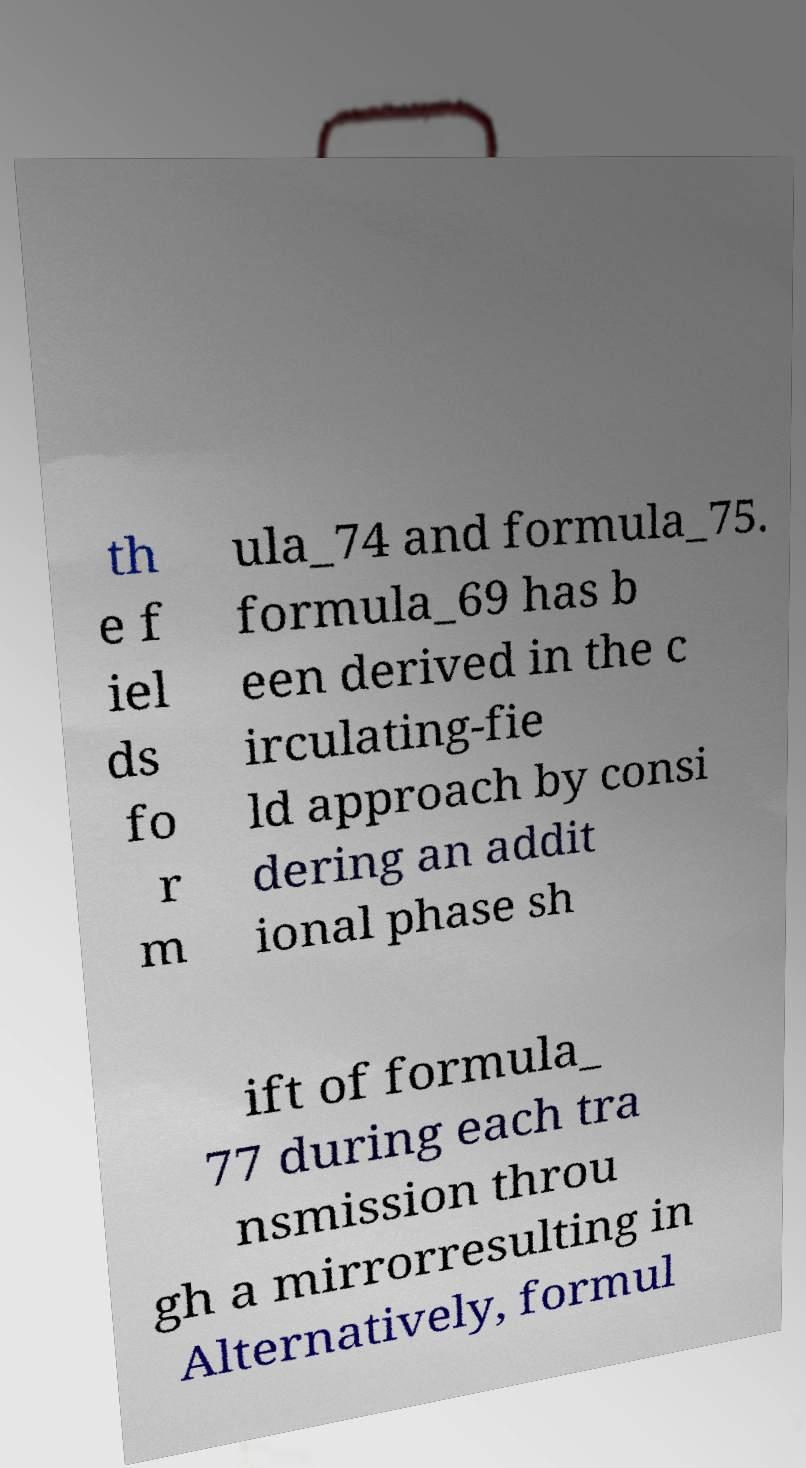Can you accurately transcribe the text from the provided image for me? th e f iel ds fo r m ula_74 and formula_75. formula_69 has b een derived in the c irculating-fie ld approach by consi dering an addit ional phase sh ift of formula_ 77 during each tra nsmission throu gh a mirrorresulting in Alternatively, formul 